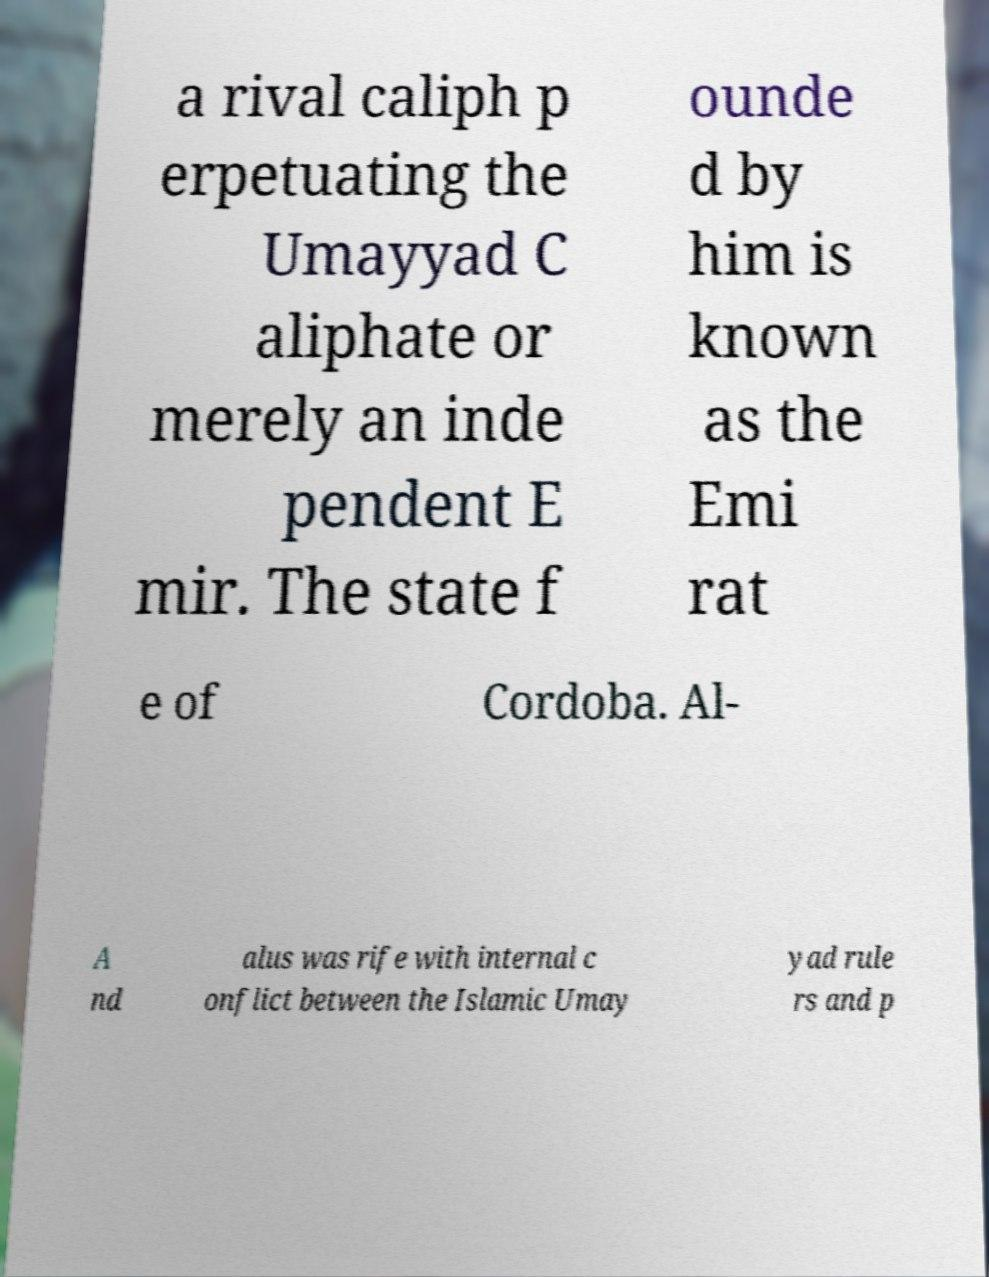Please identify and transcribe the text found in this image. a rival caliph p erpetuating the Umayyad C aliphate or merely an inde pendent E mir. The state f ounde d by him is known as the Emi rat e of Cordoba. Al- A nd alus was rife with internal c onflict between the Islamic Umay yad rule rs and p 